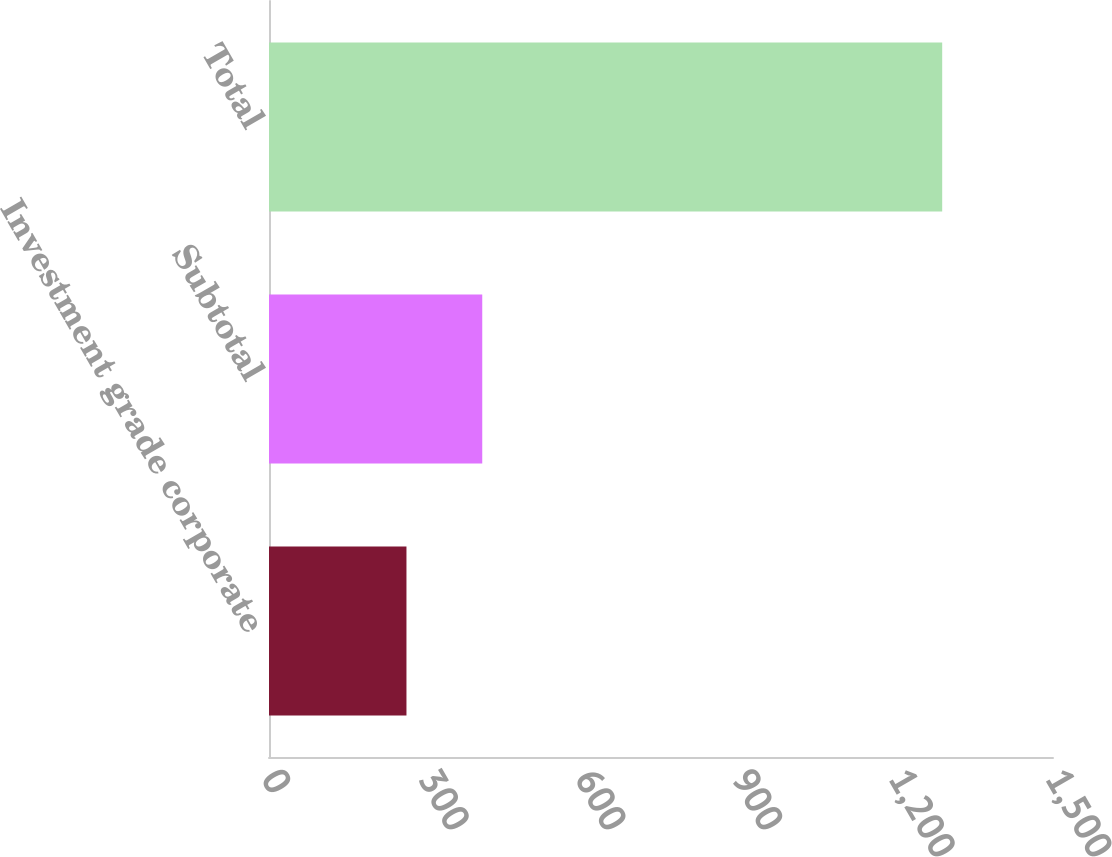Convert chart to OTSL. <chart><loc_0><loc_0><loc_500><loc_500><bar_chart><fcel>Investment grade corporate<fcel>Subtotal<fcel>Total<nl><fcel>263<fcel>408<fcel>1288<nl></chart> 